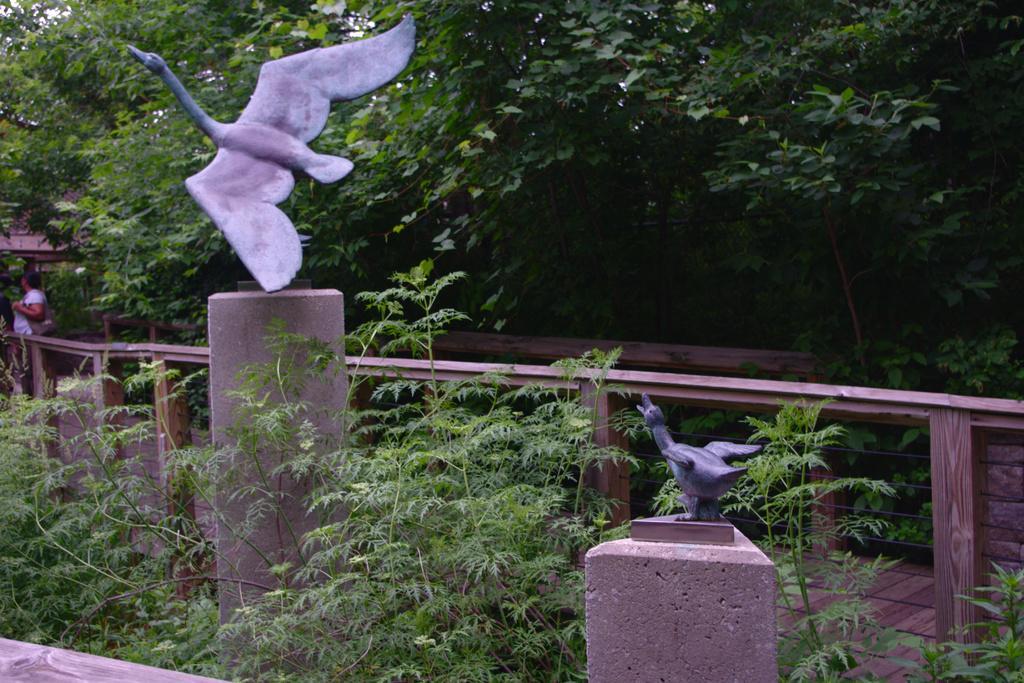Can you describe this image briefly? As we can see in the image there are plants, bird statues, tree and a person standing in the background. 